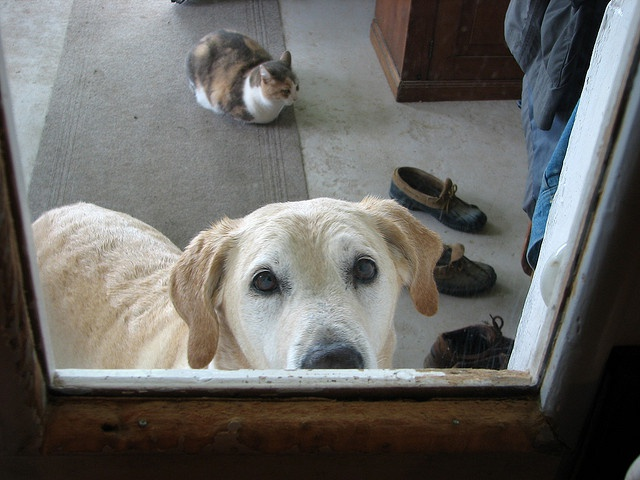Describe the objects in this image and their specific colors. I can see dog in darkgray, lightgray, and gray tones and cat in darkgray, gray, and black tones in this image. 